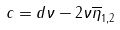Convert formula to latex. <formula><loc_0><loc_0><loc_500><loc_500>c = d \nu - 2 \nu \overline { \eta } _ { 1 , 2 }</formula> 